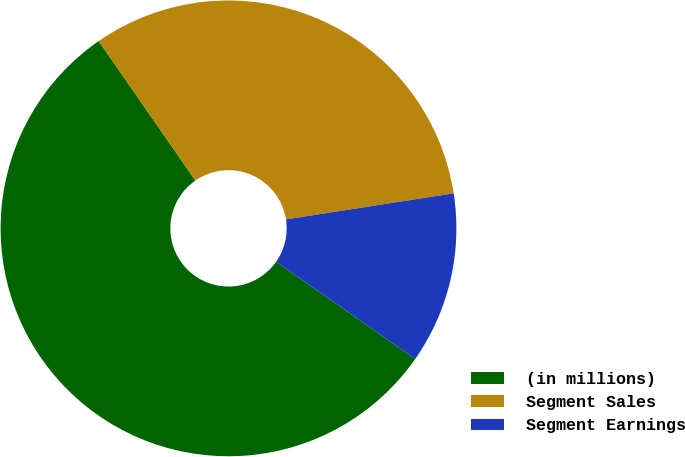Convert chart. <chart><loc_0><loc_0><loc_500><loc_500><pie_chart><fcel>(in millions)<fcel>Segment Sales<fcel>Segment Earnings<nl><fcel>55.64%<fcel>32.19%<fcel>12.17%<nl></chart> 